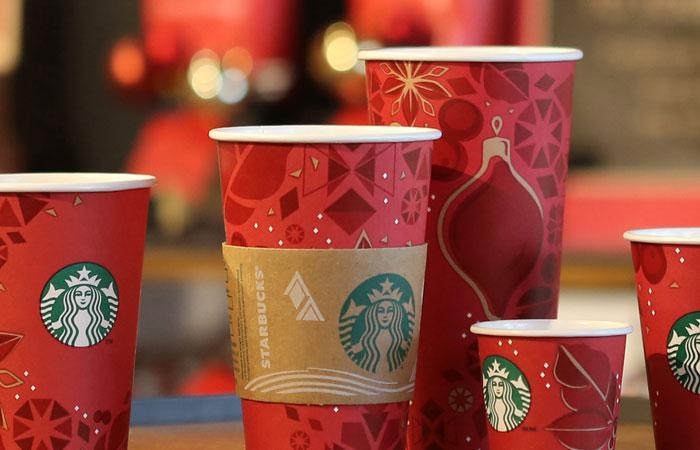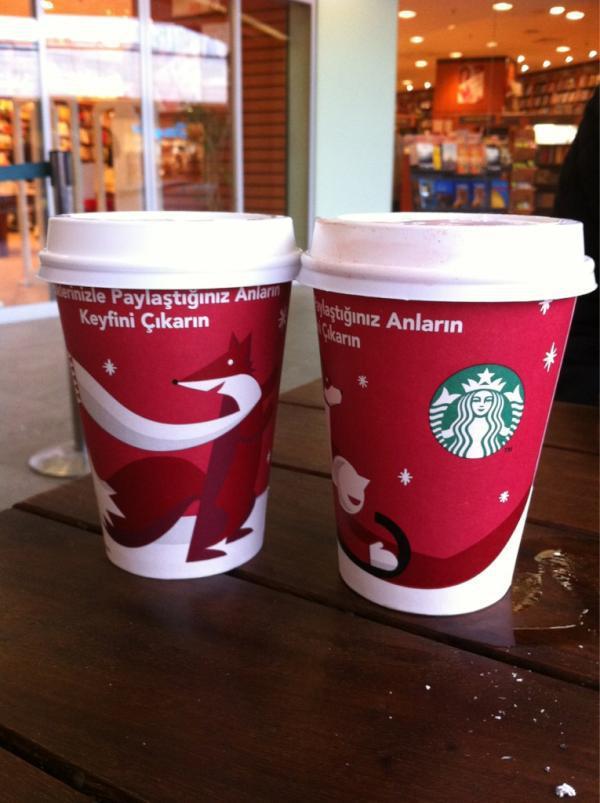The first image is the image on the left, the second image is the image on the right. For the images shown, is this caption "At least one image includes a white cup with a lid on it and an illustration of holding hands on its front." true? Answer yes or no. No. The first image is the image on the left, the second image is the image on the right. For the images shown, is this caption "There is a single cup in one of the images." true? Answer yes or no. No. 